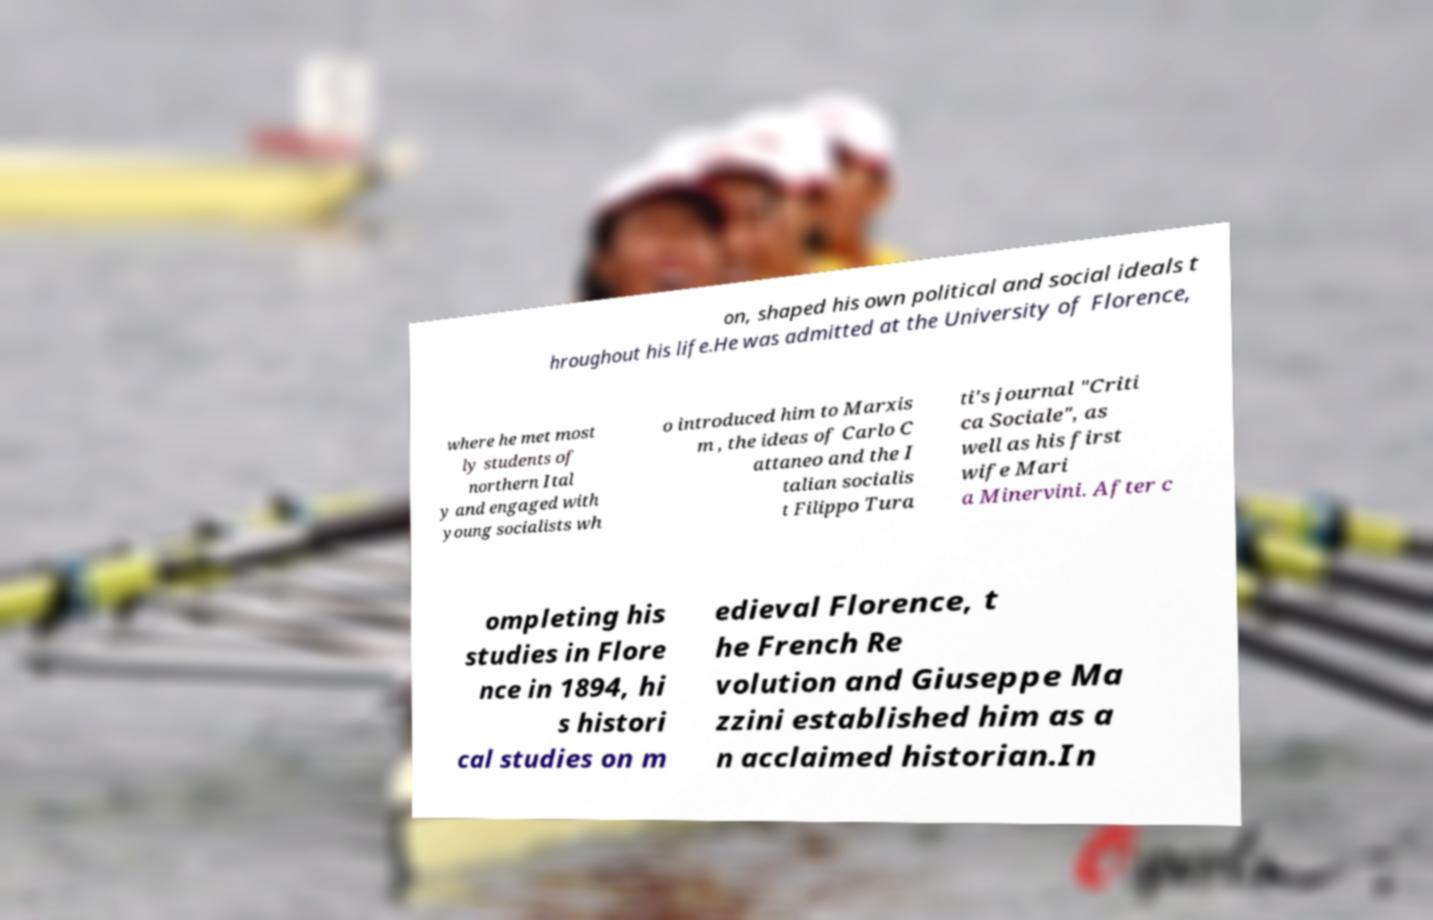What messages or text are displayed in this image? I need them in a readable, typed format. on, shaped his own political and social ideals t hroughout his life.He was admitted at the University of Florence, where he met most ly students of northern Ital y and engaged with young socialists wh o introduced him to Marxis m , the ideas of Carlo C attaneo and the I talian socialis t Filippo Tura ti's journal "Criti ca Sociale", as well as his first wife Mari a Minervini. After c ompleting his studies in Flore nce in 1894, hi s histori cal studies on m edieval Florence, t he French Re volution and Giuseppe Ma zzini established him as a n acclaimed historian.In 